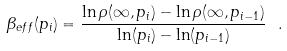<formula> <loc_0><loc_0><loc_500><loc_500>\beta _ { e f f } ( p _ { i } ) = \frac { \ln \rho ( \infty , p _ { i } ) - \ln \rho ( \infty , p _ { i - 1 } ) } { \ln ( p _ { i } ) - \ln ( p _ { i - 1 } ) } \ .</formula> 